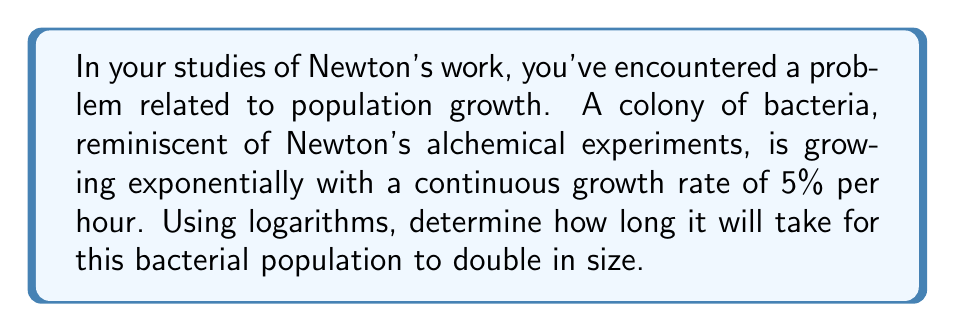Teach me how to tackle this problem. Let's approach this step-by-step using logarithms:

1) The formula for exponential growth is:
   $$A = P \cdot e^{rt}$$
   where $A$ is the final amount, $P$ is the initial amount, $r$ is the growth rate, and $t$ is time.

2) For doubling, we have $A = 2P$. Substituting this into our equation:
   $$2P = P \cdot e^{rt}$$

3) Dividing both sides by $P$:
   $$2 = e^{rt}$$

4) Taking the natural logarithm of both sides:
   $$\ln(2) = \ln(e^{rt})$$

5) Using the logarithm property $\ln(e^x) = x$:
   $$\ln(2) = rt$$

6) Solving for $t$:
   $$t = \frac{\ln(2)}{r}$$

7) We're given $r = 0.05$ (5% = 0.05). Substituting this:
   $$t = \frac{\ln(2)}{0.05}$$

8) Calculating this:
   $$t \approx 13.86 \text{ hours}$$

This method, using logarithms to solve exponential equations, would have been familiar to Newton, who made significant contributions to the development of calculus and the study of natural logarithms.
Answer: $13.86$ hours 